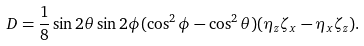Convert formula to latex. <formula><loc_0><loc_0><loc_500><loc_500>D = \frac { 1 } { 8 } \sin 2 \theta \sin 2 \phi ( \cos ^ { 2 } \phi - \cos ^ { 2 } \theta ) ( \eta _ { z } \zeta _ { x } - \eta _ { x } \zeta _ { z } ) .</formula> 